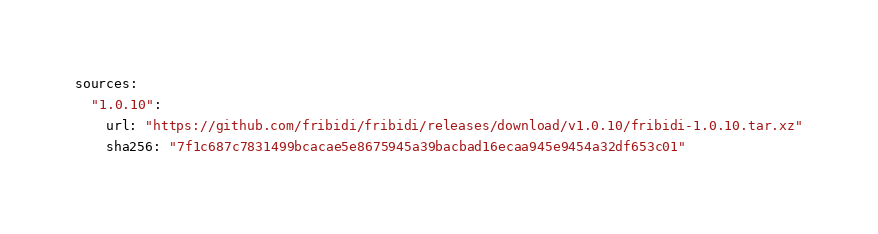<code> <loc_0><loc_0><loc_500><loc_500><_YAML_>sources:
  "1.0.10":
    url: "https://github.com/fribidi/fribidi/releases/download/v1.0.10/fribidi-1.0.10.tar.xz"
    sha256: "7f1c687c7831499bcacae5e8675945a39bacbad16ecaa945e9454a32df653c01"</code> 